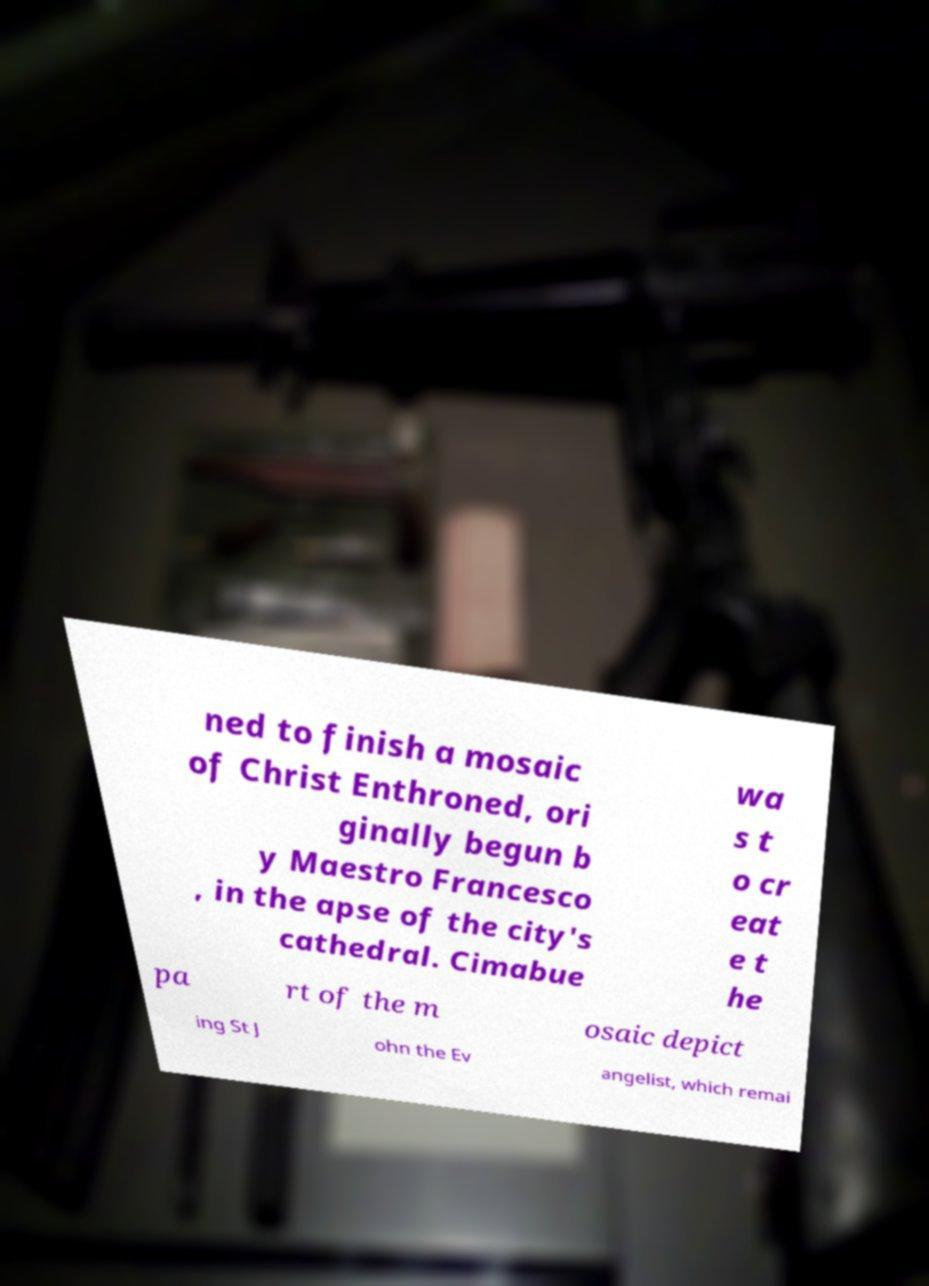Can you accurately transcribe the text from the provided image for me? ned to finish a mosaic of Christ Enthroned, ori ginally begun b y Maestro Francesco , in the apse of the city's cathedral. Cimabue wa s t o cr eat e t he pa rt of the m osaic depict ing St J ohn the Ev angelist, which remai 